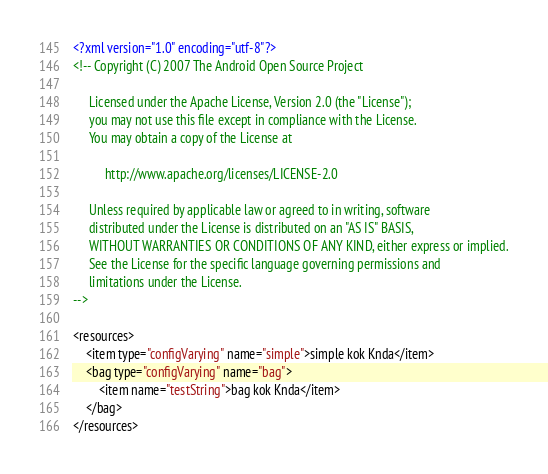Convert code to text. <code><loc_0><loc_0><loc_500><loc_500><_XML_><?xml version="1.0" encoding="utf-8"?>
<!-- Copyright (C) 2007 The Android Open Source Project

     Licensed under the Apache License, Version 2.0 (the "License");
     you may not use this file except in compliance with the License.
     You may obtain a copy of the License at
  
          http://www.apache.org/licenses/LICENSE-2.0
  
     Unless required by applicable law or agreed to in writing, software
     distributed under the License is distributed on an "AS IS" BASIS,
     WITHOUT WARRANTIES OR CONDITIONS OF ANY KIND, either express or implied.
     See the License for the specific language governing permissions and
     limitations under the License.
-->

<resources>
    <item type="configVarying" name="simple">simple kok Knda</item>
    <bag type="configVarying" name="bag">
        <item name="testString">bag kok Knda</item>
    </bag>
</resources>
</code> 